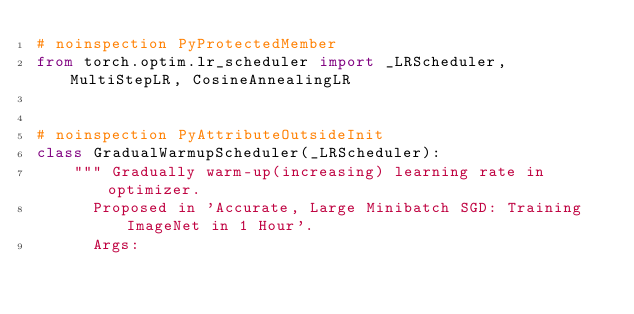Convert code to text. <code><loc_0><loc_0><loc_500><loc_500><_Python_># noinspection PyProtectedMember
from torch.optim.lr_scheduler import _LRScheduler, MultiStepLR, CosineAnnealingLR


# noinspection PyAttributeOutsideInit
class GradualWarmupScheduler(_LRScheduler):
    """ Gradually warm-up(increasing) learning rate in optimizer.
      Proposed in 'Accurate, Large Minibatch SGD: Training ImageNet in 1 Hour'.
      Args:</code> 